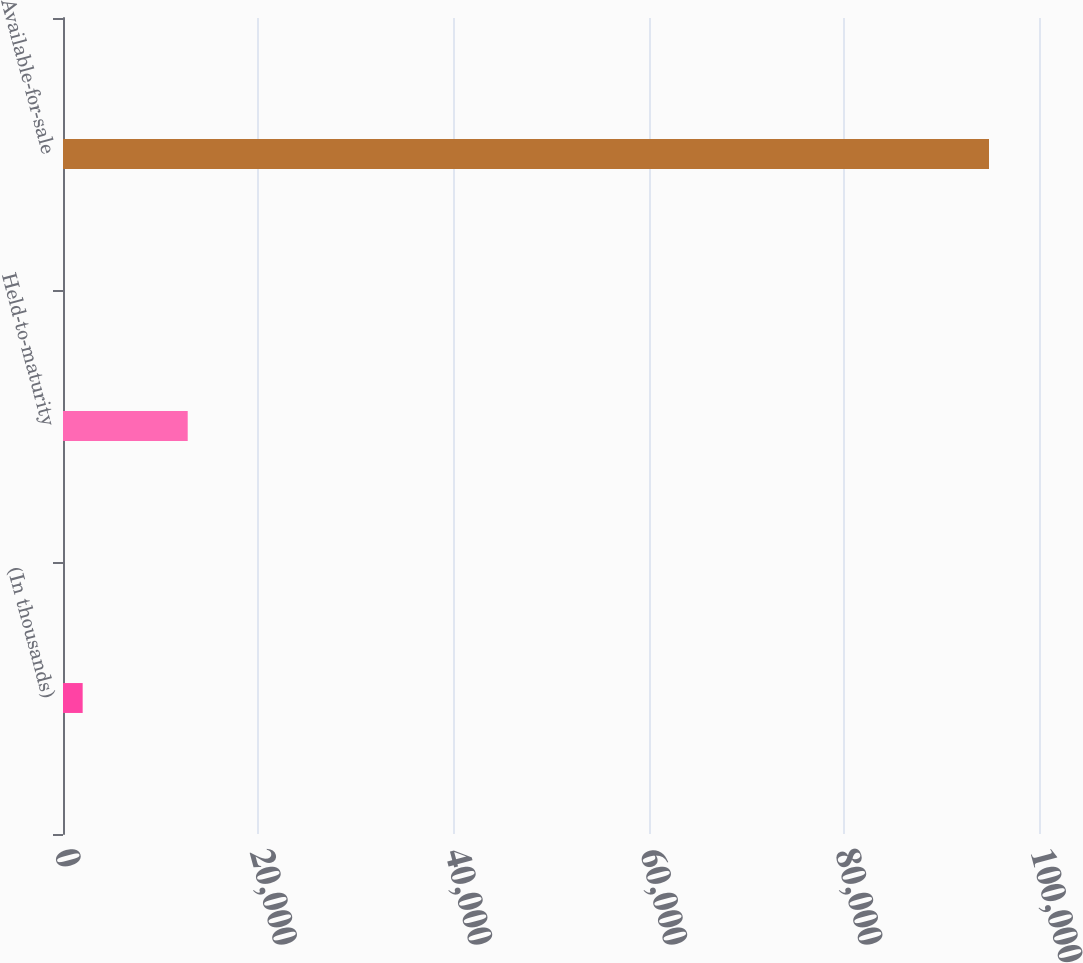Convert chart to OTSL. <chart><loc_0><loc_0><loc_500><loc_500><bar_chart><fcel>(In thousands)<fcel>Held-to-maturity<fcel>Available-for-sale<nl><fcel>2015<fcel>12777<fcel>94877<nl></chart> 